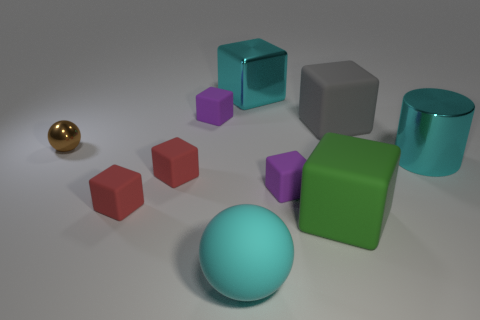Subtract all cyan cubes. How many cubes are left? 6 Subtract all big matte blocks. How many blocks are left? 5 Subtract all blue cubes. Subtract all gray spheres. How many cubes are left? 7 Subtract all cylinders. How many objects are left? 9 Add 5 tiny red matte objects. How many tiny red matte objects exist? 7 Subtract 0 yellow cubes. How many objects are left? 10 Subtract all tiny purple rubber things. Subtract all tiny brown metal spheres. How many objects are left? 7 Add 2 red objects. How many red objects are left? 4 